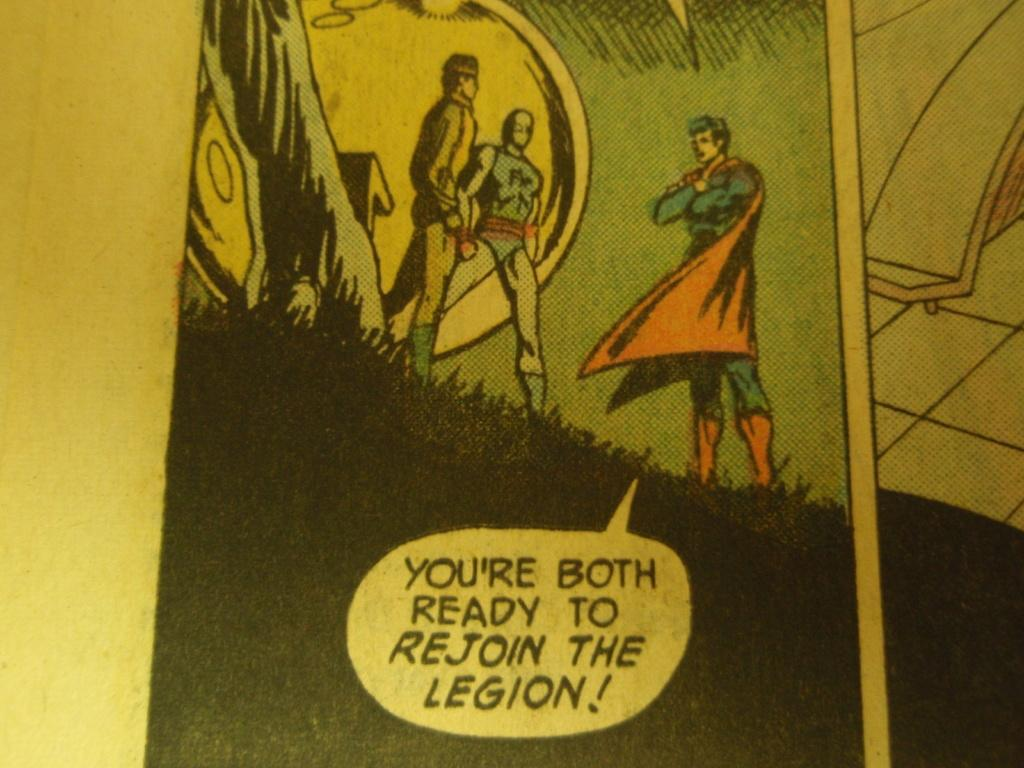<image>
Give a short and clear explanation of the subsequent image. A cartoon which reads 'You're both ready to rejoin the legion.' 